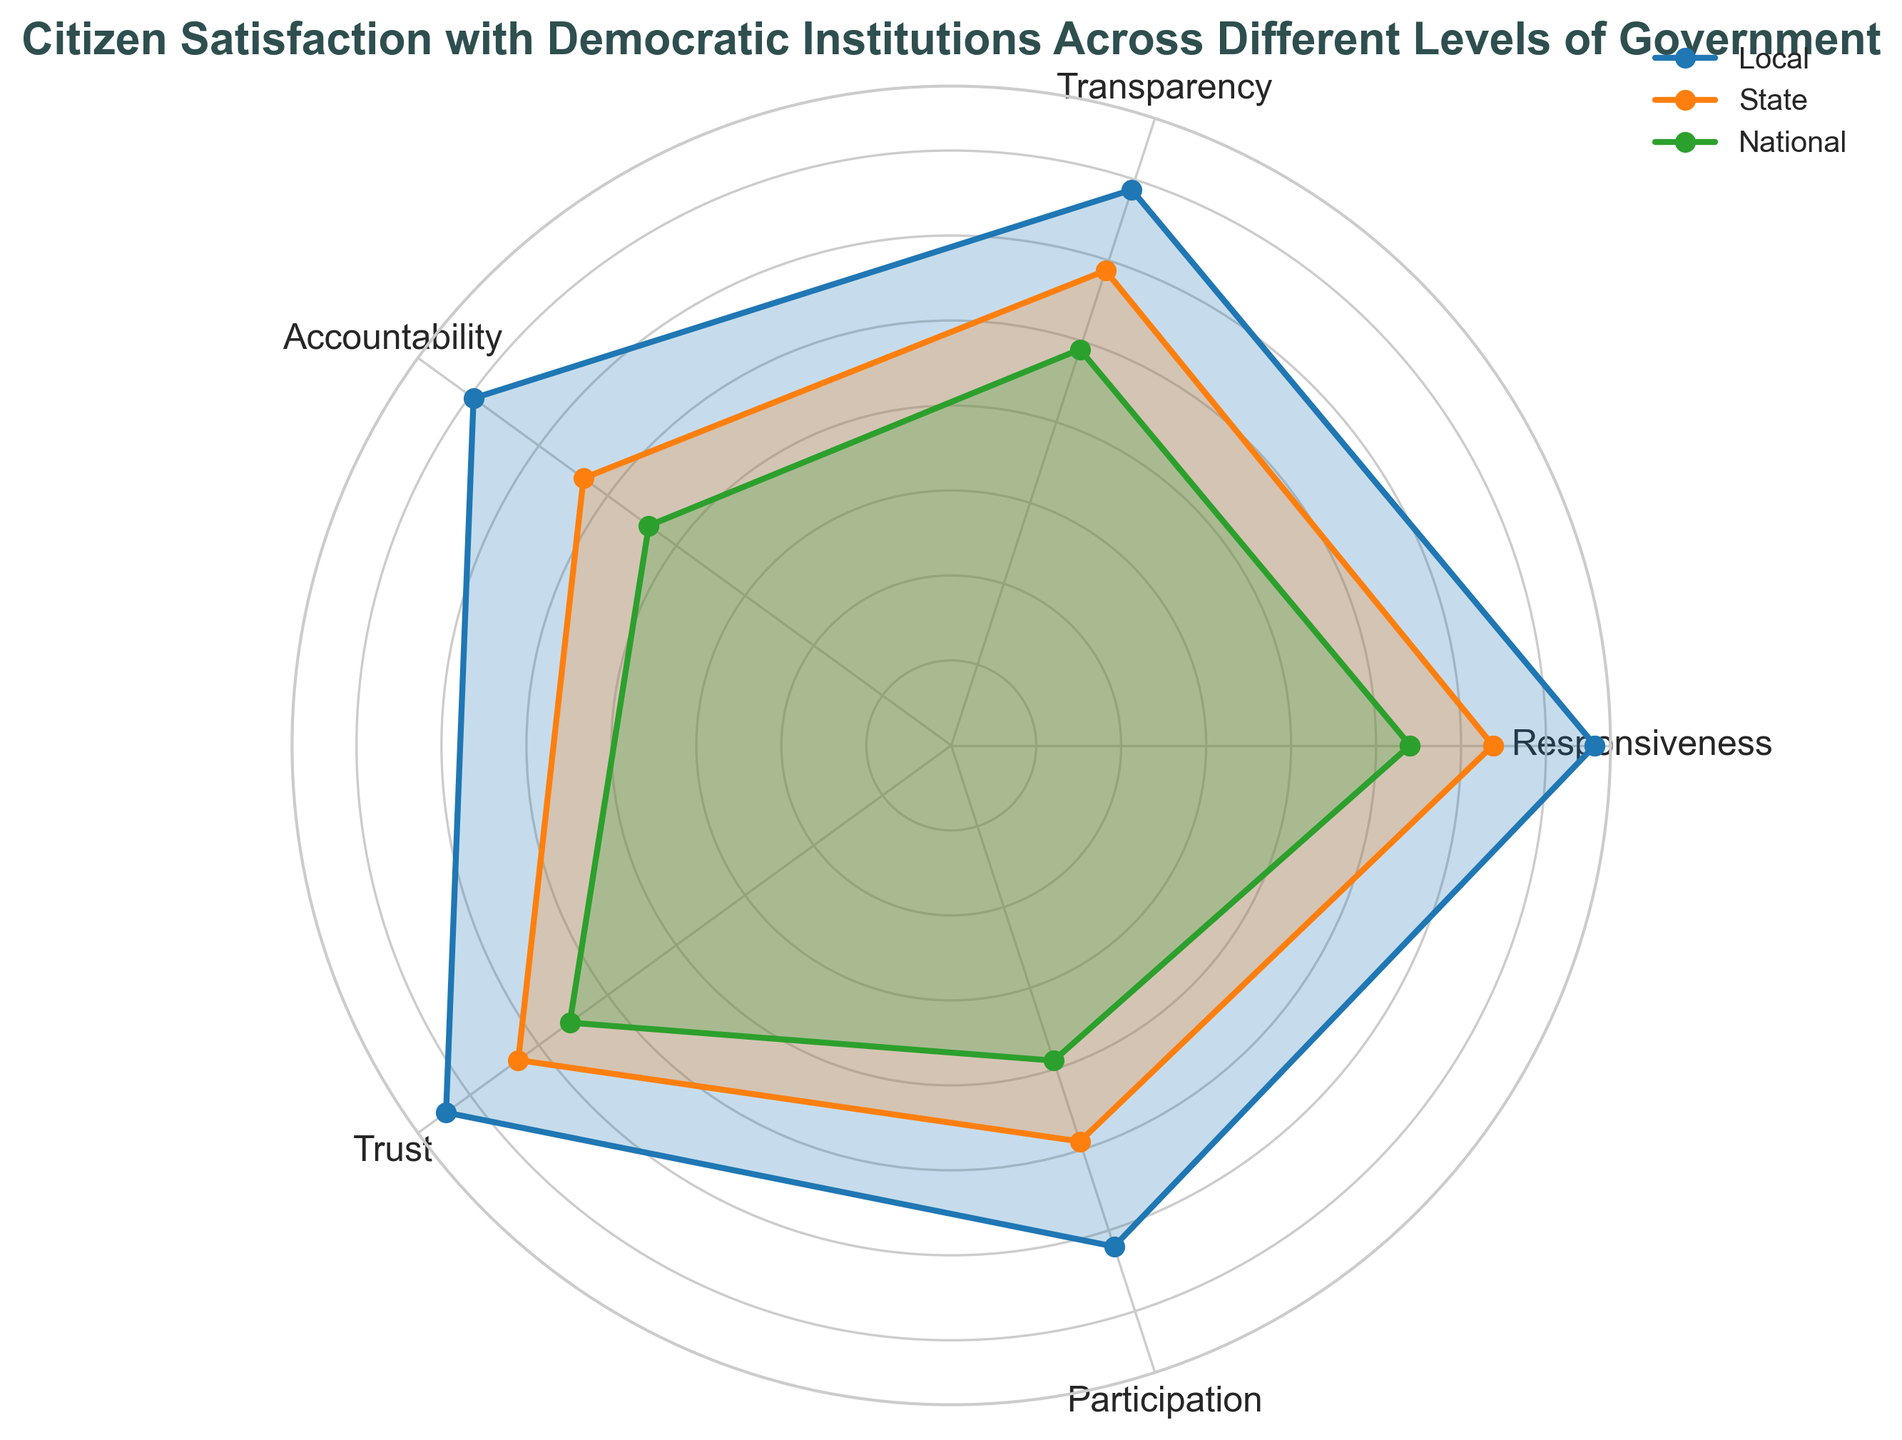What level of government has the highest average citizen satisfaction across all categories? To determine the level of government with the highest average satisfaction, sum up the average percentage values for each category (Responsiveness, Transparency, Accountability, Trust, Participation) for Local, State, and National levels, and then find which level has the highest total. Local: (70+80+75+78)/4 = 75.75, State: (63+65+67+67)/4 = 65.5, National: (53+55+58+58)/4 = 56 => Local has the highest average satisfaction.
Answer: Local On average, how much more responsive is the Local government compared to the National government? Calculate the difference between the average responsiveness percentages for Local and National levels. Local: (70 + 80 + 75 + 78)/4 = 75.75, National: (53 + 55 + 58 + 58)/4 = 56, 75.75 - 56 = 19.75
Answer: 19.75 Between which two levels of government is the difference in citizen participation the greatest? Compare the average citizen participation percentages for Local, State, and National levels and find the pair with the largest difference. Local: (55 + 65 + 60 + 68)/4 = 62, State: (45 + 50 + 48 + 53)/4 = 49, National: (35 + 40 + 38 + 43)/4 = 39, the greatest difference is between Local and National which is 62 - 39 = 23.
Answer: Local and National Which level of government shows the least variation in citizen trust based on the radar chart? To identify the level with the least variation, observe the spread of the data points for Trust for each level. Local: ~75 (sum data points for visual estimation), State: ~63.25, National: ~53.75. Local shows least variation since its trust values are highest with smaller differences.
Answer: Local What categories are above average for Local government satisfaction compared to its own other categories? Calculate the average satisfaction score for Local across all categories and then see which specific categories are above this average. Local Average: (70 + 75 + 78 + 80 + 75 + 78 + 75 + 72 + 68)/5 ≈ 71.8. Responsiveness = 75.75 > 71.8, Transparency = 68.75 < 71.8, Accountability = 66.5 < 71.8, Trust = 76.25 > 71.8, Participation = 62 > 71.8 => Responsiveness and Trust are above average.
Answer: Responsiveness and Trust 